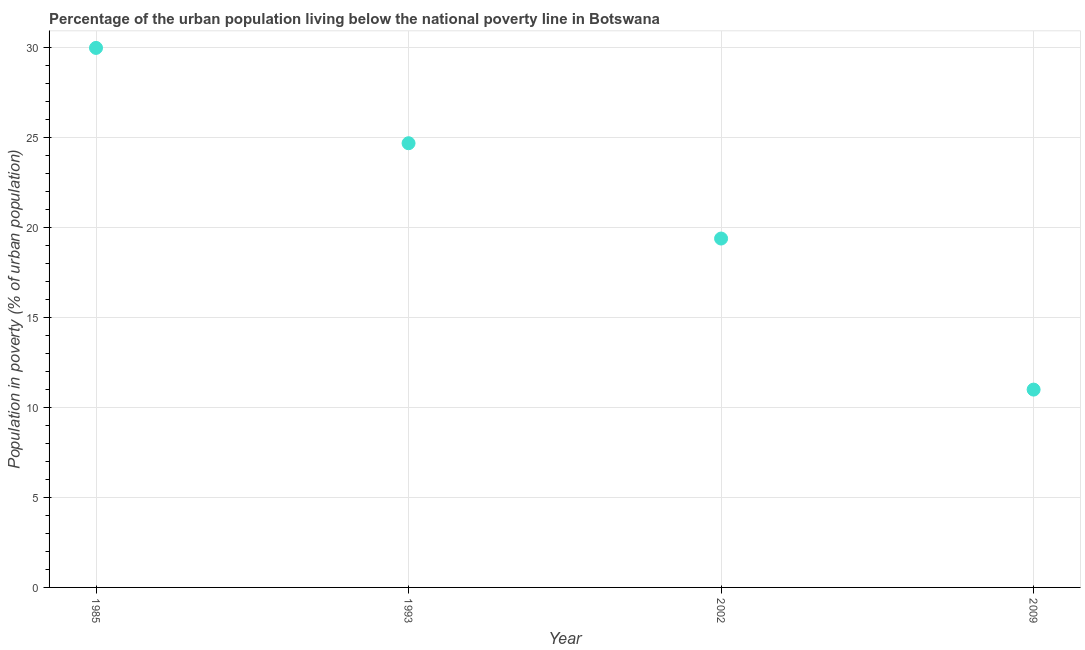Across all years, what is the maximum percentage of urban population living below poverty line?
Ensure brevity in your answer.  30. Across all years, what is the minimum percentage of urban population living below poverty line?
Make the answer very short. 11. In which year was the percentage of urban population living below poverty line maximum?
Your answer should be compact. 1985. In which year was the percentage of urban population living below poverty line minimum?
Offer a terse response. 2009. What is the sum of the percentage of urban population living below poverty line?
Give a very brief answer. 85.1. What is the difference between the percentage of urban population living below poverty line in 1985 and 1993?
Your answer should be very brief. 5.3. What is the average percentage of urban population living below poverty line per year?
Your response must be concise. 21.27. What is the median percentage of urban population living below poverty line?
Give a very brief answer. 22.05. Do a majority of the years between 2009 and 1985 (inclusive) have percentage of urban population living below poverty line greater than 25 %?
Ensure brevity in your answer.  Yes. What is the ratio of the percentage of urban population living below poverty line in 2002 to that in 2009?
Your response must be concise. 1.76. Is the percentage of urban population living below poverty line in 1993 less than that in 2002?
Offer a very short reply. No. Is the difference between the percentage of urban population living below poverty line in 1993 and 2009 greater than the difference between any two years?
Your answer should be compact. No. What is the difference between the highest and the second highest percentage of urban population living below poverty line?
Provide a succinct answer. 5.3. Is the sum of the percentage of urban population living below poverty line in 1993 and 2002 greater than the maximum percentage of urban population living below poverty line across all years?
Offer a very short reply. Yes. In how many years, is the percentage of urban population living below poverty line greater than the average percentage of urban population living below poverty line taken over all years?
Ensure brevity in your answer.  2. Does the percentage of urban population living below poverty line monotonically increase over the years?
Provide a short and direct response. No. What is the difference between two consecutive major ticks on the Y-axis?
Make the answer very short. 5. What is the title of the graph?
Offer a very short reply. Percentage of the urban population living below the national poverty line in Botswana. What is the label or title of the X-axis?
Offer a terse response. Year. What is the label or title of the Y-axis?
Your answer should be compact. Population in poverty (% of urban population). What is the Population in poverty (% of urban population) in 1993?
Offer a terse response. 24.7. What is the Population in poverty (% of urban population) in 2002?
Provide a succinct answer. 19.4. What is the difference between the Population in poverty (% of urban population) in 1985 and 2009?
Offer a terse response. 19. What is the difference between the Population in poverty (% of urban population) in 1993 and 2002?
Provide a succinct answer. 5.3. What is the difference between the Population in poverty (% of urban population) in 1993 and 2009?
Your answer should be very brief. 13.7. What is the ratio of the Population in poverty (% of urban population) in 1985 to that in 1993?
Ensure brevity in your answer.  1.22. What is the ratio of the Population in poverty (% of urban population) in 1985 to that in 2002?
Provide a succinct answer. 1.55. What is the ratio of the Population in poverty (% of urban population) in 1985 to that in 2009?
Provide a short and direct response. 2.73. What is the ratio of the Population in poverty (% of urban population) in 1993 to that in 2002?
Keep it short and to the point. 1.27. What is the ratio of the Population in poverty (% of urban population) in 1993 to that in 2009?
Ensure brevity in your answer.  2.25. What is the ratio of the Population in poverty (% of urban population) in 2002 to that in 2009?
Provide a succinct answer. 1.76. 